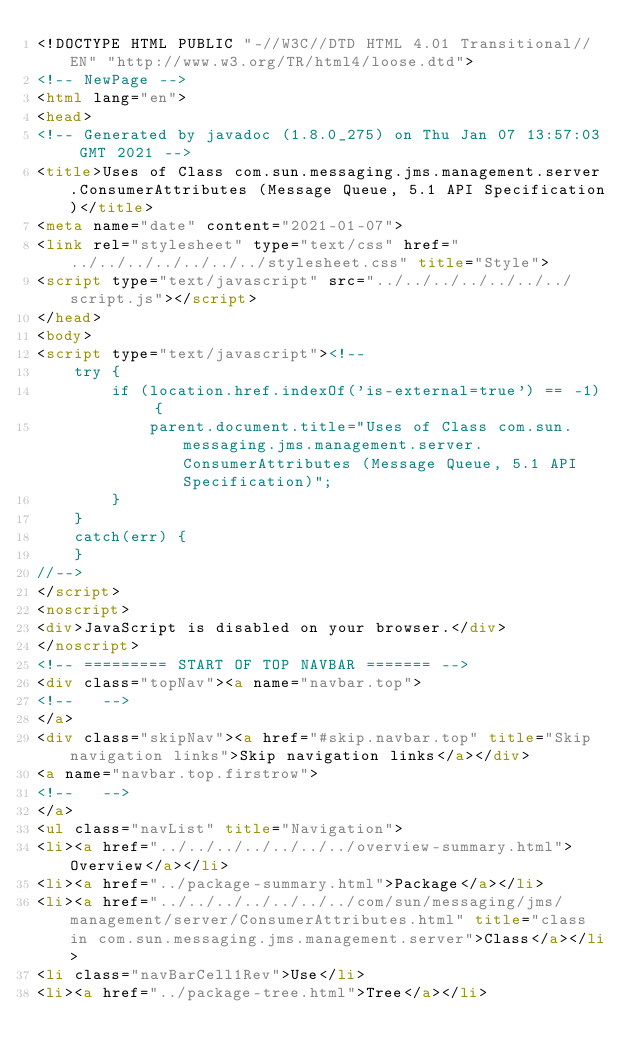<code> <loc_0><loc_0><loc_500><loc_500><_HTML_><!DOCTYPE HTML PUBLIC "-//W3C//DTD HTML 4.01 Transitional//EN" "http://www.w3.org/TR/html4/loose.dtd">
<!-- NewPage -->
<html lang="en">
<head>
<!-- Generated by javadoc (1.8.0_275) on Thu Jan 07 13:57:03 GMT 2021 -->
<title>Uses of Class com.sun.messaging.jms.management.server.ConsumerAttributes (Message Queue, 5.1 API Specification)</title>
<meta name="date" content="2021-01-07">
<link rel="stylesheet" type="text/css" href="../../../../../../../stylesheet.css" title="Style">
<script type="text/javascript" src="../../../../../../../script.js"></script>
</head>
<body>
<script type="text/javascript"><!--
    try {
        if (location.href.indexOf('is-external=true') == -1) {
            parent.document.title="Uses of Class com.sun.messaging.jms.management.server.ConsumerAttributes (Message Queue, 5.1 API Specification)";
        }
    }
    catch(err) {
    }
//-->
</script>
<noscript>
<div>JavaScript is disabled on your browser.</div>
</noscript>
<!-- ========= START OF TOP NAVBAR ======= -->
<div class="topNav"><a name="navbar.top">
<!--   -->
</a>
<div class="skipNav"><a href="#skip.navbar.top" title="Skip navigation links">Skip navigation links</a></div>
<a name="navbar.top.firstrow">
<!--   -->
</a>
<ul class="navList" title="Navigation">
<li><a href="../../../../../../../overview-summary.html">Overview</a></li>
<li><a href="../package-summary.html">Package</a></li>
<li><a href="../../../../../../../com/sun/messaging/jms/management/server/ConsumerAttributes.html" title="class in com.sun.messaging.jms.management.server">Class</a></li>
<li class="navBarCell1Rev">Use</li>
<li><a href="../package-tree.html">Tree</a></li></code> 